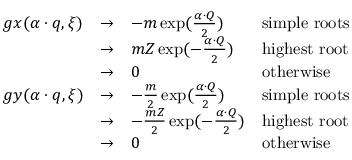Convert formula to latex. <formula><loc_0><loc_0><loc_500><loc_500>\begin{array} { l l l l } { g x ( \alpha \cdot q , \xi ) } & { \rightarrow } & { { - m \exp ( { \frac { \alpha \cdot Q } { 2 } } ) } } & { s i m p l e r o o t s } & { \rightarrow } & { { { m Z } \exp ( - { \frac { \alpha \cdot Q } { 2 } } ) } } & { h i g h e s t r o o t } & { \rightarrow } & { 0 } & { o t h e r w i s e } \\ { g y ( \alpha \cdot q , \xi ) } & { \rightarrow } & { { - { \frac { m } { 2 } } \exp ( { \frac { \alpha \cdot Q } { 2 } } ) } } & { s i m p l e r o o t s } & { \rightarrow } & { { - { \frac { m Z } { 2 } } \exp ( - { \frac { \alpha \cdot Q } { 2 } } ) } } & { h i g h e s t r o o t } & { \rightarrow } & { 0 } & { o t h e r w i s e } \end{array}</formula> 